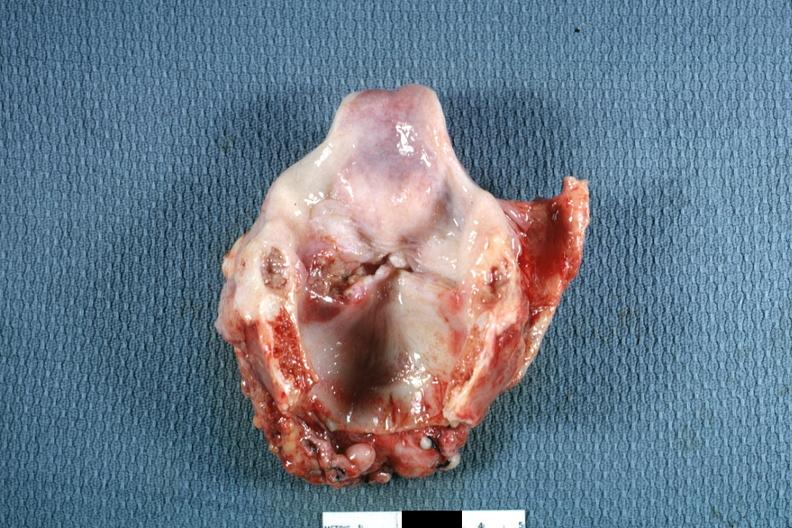s squamous cell carcinoma present?
Answer the question using a single word or phrase. Yes 